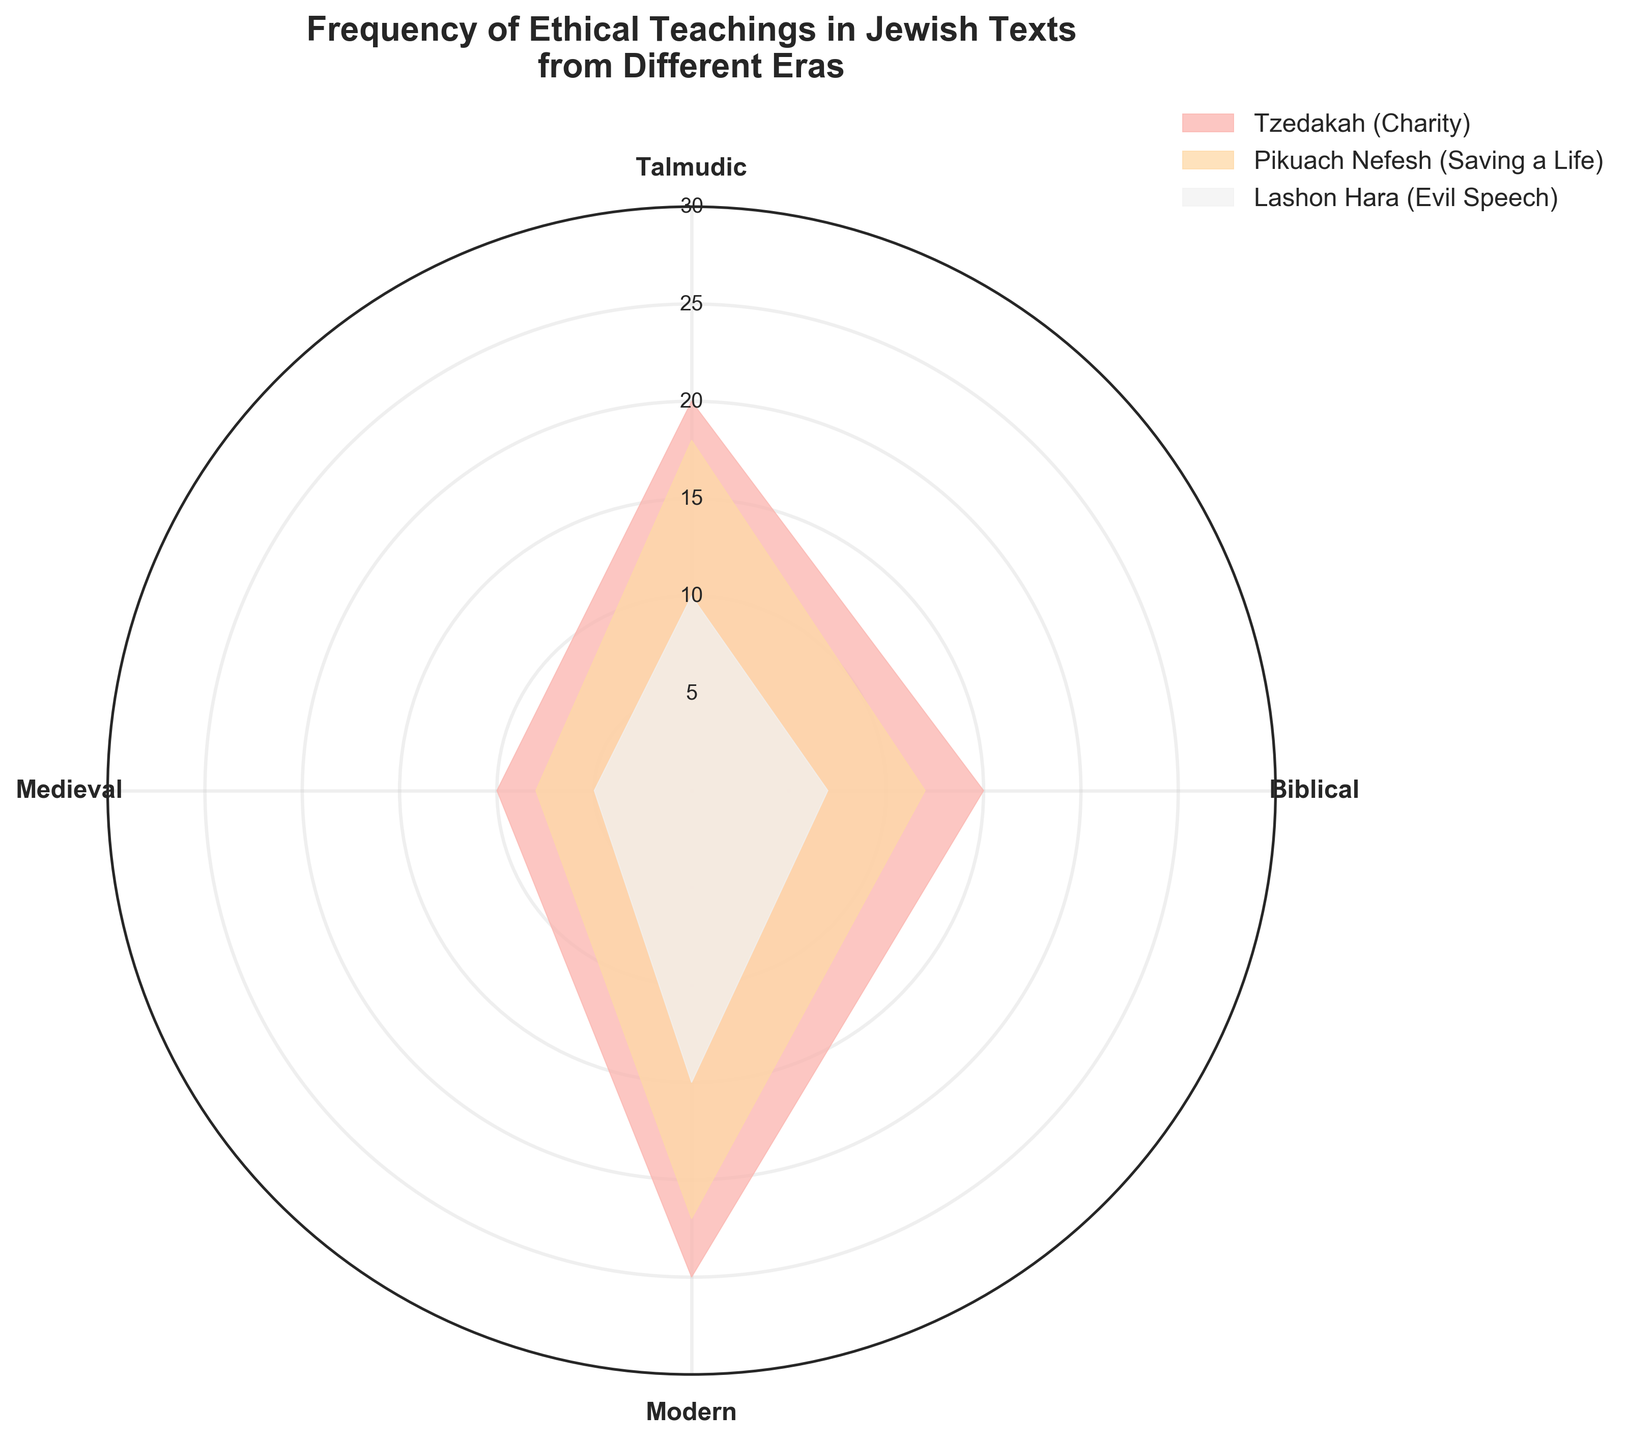What is the frequency of Tzedakah (Charity) in the Modern era? Find the "Modern" section in the plot and then locate the segment for Tzedakah (Charity). The frequency value is represented by the radial distance from the center to the edge of that segment.
Answer: 25 Which ethical teaching in the Talmudic era has the highest frequency? Locate the "Talmudic" section in the plot and compare the radial distances for Tzedakah (Charity), Pikuach Nefesh (Saving a Life), and Lashon Hara (Evil Speech). The longest radial line would indicate the highest frequency.
Answer: Tzedakah (Charity) How do the frequencies of Pikuach Nefesh (Saving a Life) compare between the Biblical and Medieval eras? Find the segments for Pikuach Nefesh (Saving a Life) in both the "Biblical" and "Medieval" sections. Compare the lengths of the radial lines for each era.
Answer: Biblical: 12, Medieval: 8 What is the total frequency of Lashon Hara (Evil Speech) across all eras combined? Sum the frequencies of Lashon Hara (Evil Speech) in the Biblical, Talmudic, Medieval, and Modern eras: 7 + 10 + 5 + 15.
Answer: 37 In which era is the frequency of Pikuach Nefesh (Saving a Life) the lowest? Compare the radial lengths of Pikuach Nefesh (Saving a Life) in all eras (Biblical, Talmudic, Medieval, Modern) and identify the shortest one.
Answer: Medieval How much higher is the frequency of Tzedakah (Charity) in the Modern era compared to the Medieval era? Subtract the frequency of Tzedakah (Charity) in the Medieval era from that in the Modern era: 25 - 10.
Answer: 15 Which ethical teaching shows a consistent increase in frequency from the Biblical to the Modern era? For each ethical teaching, check the radial lengths in successive eras (Biblical, Talmudic, Medieval, Modern). Identify the one that increases consistently.
Answer: Tzedakah (Charity) In the Talmudic era, what is the difference in frequency between Pikuach Nefesh (Saving a Life) and Lashon Hara (Evil Speech)? Find the radial lengths for Pikuach Nefesh (Saving a Life) and Lashon Hara (Evil Speech) in the "Talmudic" section. Subtract the smaller from the larger: 18 - 10.
Answer: 8 Compare the frequency of Lashon Hara (Evil Speech) in the Biblical era to Tzedakah (Charity) in the Medieval era. Which one is higher? Locate the radial lengths for Lashon Hara (Evil Speech) in the "Biblical" section and Tzedakah (Charity) in the "Medieval" section. Compare the lengths.
Answer: Tzedakah (Charity) in the Medieval era 